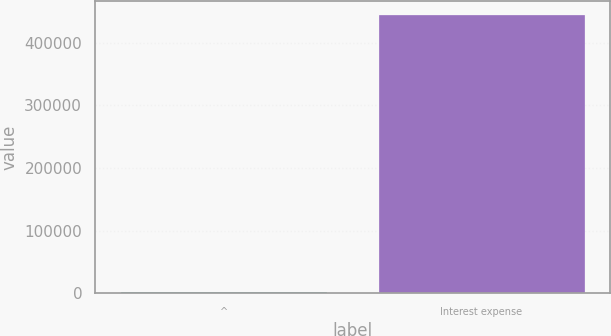<chart> <loc_0><loc_0><loc_500><loc_500><bar_chart><fcel>^<fcel>Interest expense<nl><fcel>2013<fcel>444412<nl></chart> 